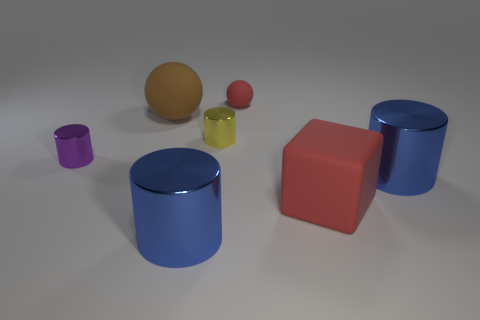Add 1 small matte objects. How many objects exist? 8 Subtract all spheres. How many objects are left? 5 Add 2 big cubes. How many big cubes exist? 3 Subtract 0 purple balls. How many objects are left? 7 Subtract all purple metallic cylinders. Subtract all yellow metal objects. How many objects are left? 5 Add 4 blue things. How many blue things are left? 6 